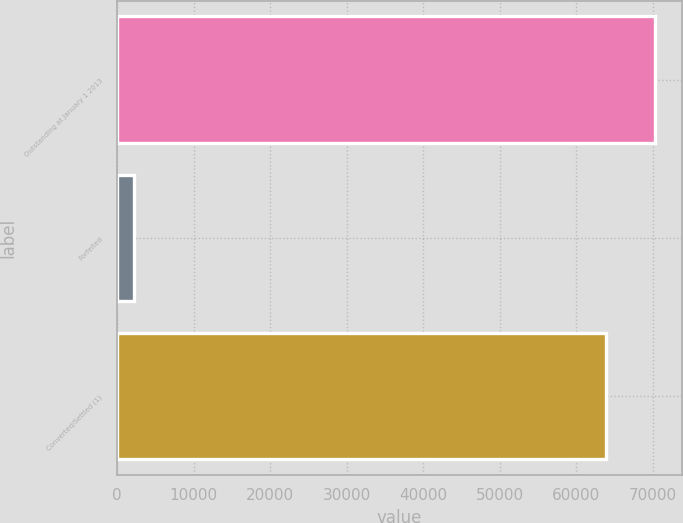<chart> <loc_0><loc_0><loc_500><loc_500><bar_chart><fcel>Outstanding at January 1 2013<fcel>Forfeited<fcel>Converted/Settled (1)<nl><fcel>70299.9<fcel>2228<fcel>63909<nl></chart> 